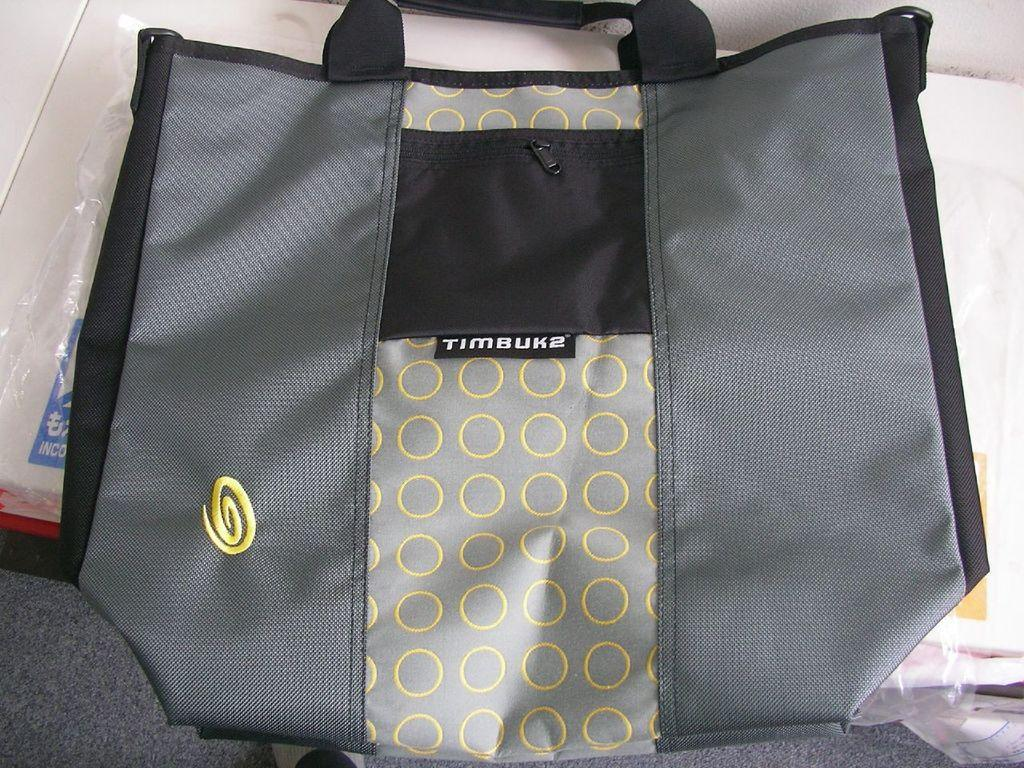What is the color of the bag in the image? The bag in the image is grey. Are there any patterns or designs on the bag? Yes, there are yellow color circles on the bag. What is written on the bag? The text "timbuk2" is written on the bag. How many celery stalks are sticking out of the bag in the image? There are no celery stalks present in the image; it only features a grey bag with yellow circles and the text "timbuk2." 